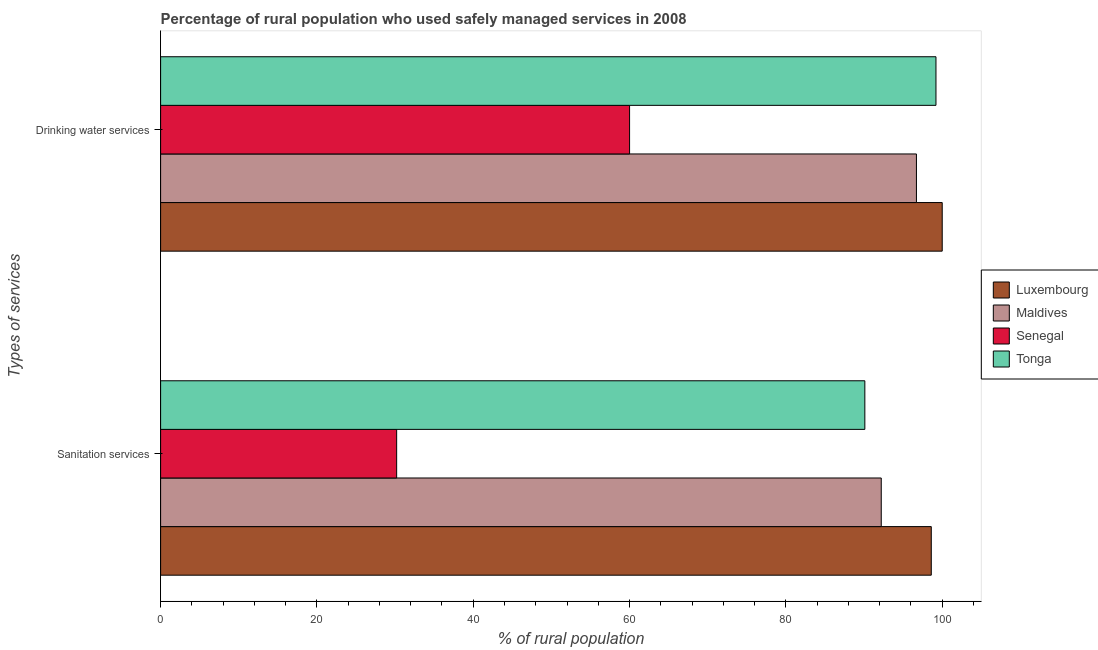How many bars are there on the 2nd tick from the bottom?
Offer a very short reply. 4. What is the label of the 1st group of bars from the top?
Provide a short and direct response. Drinking water services. What is the percentage of rural population who used sanitation services in Tonga?
Offer a very short reply. 90.1. Across all countries, what is the maximum percentage of rural population who used sanitation services?
Your answer should be very brief. 98.6. Across all countries, what is the minimum percentage of rural population who used sanitation services?
Make the answer very short. 30.2. In which country was the percentage of rural population who used drinking water services maximum?
Keep it short and to the point. Luxembourg. In which country was the percentage of rural population who used sanitation services minimum?
Provide a succinct answer. Senegal. What is the total percentage of rural population who used sanitation services in the graph?
Provide a succinct answer. 311.1. What is the difference between the percentage of rural population who used sanitation services in Luxembourg and that in Senegal?
Ensure brevity in your answer.  68.4. What is the difference between the percentage of rural population who used drinking water services in Senegal and the percentage of rural population who used sanitation services in Luxembourg?
Keep it short and to the point. -38.6. What is the average percentage of rural population who used sanitation services per country?
Make the answer very short. 77.78. What is the difference between the percentage of rural population who used drinking water services and percentage of rural population who used sanitation services in Luxembourg?
Your answer should be very brief. 1.4. What is the ratio of the percentage of rural population who used sanitation services in Senegal to that in Tonga?
Offer a terse response. 0.34. Is the percentage of rural population who used drinking water services in Luxembourg less than that in Senegal?
Ensure brevity in your answer.  No. What does the 4th bar from the top in Drinking water services represents?
Your response must be concise. Luxembourg. What does the 4th bar from the bottom in Drinking water services represents?
Keep it short and to the point. Tonga. Are all the bars in the graph horizontal?
Your response must be concise. Yes. Does the graph contain any zero values?
Offer a very short reply. No. Does the graph contain grids?
Ensure brevity in your answer.  No. Where does the legend appear in the graph?
Your answer should be compact. Center right. What is the title of the graph?
Give a very brief answer. Percentage of rural population who used safely managed services in 2008. What is the label or title of the X-axis?
Provide a succinct answer. % of rural population. What is the label or title of the Y-axis?
Make the answer very short. Types of services. What is the % of rural population of Luxembourg in Sanitation services?
Offer a very short reply. 98.6. What is the % of rural population in Maldives in Sanitation services?
Your answer should be compact. 92.2. What is the % of rural population in Senegal in Sanitation services?
Your answer should be very brief. 30.2. What is the % of rural population in Tonga in Sanitation services?
Offer a very short reply. 90.1. What is the % of rural population of Maldives in Drinking water services?
Make the answer very short. 96.7. What is the % of rural population of Senegal in Drinking water services?
Your response must be concise. 60. What is the % of rural population of Tonga in Drinking water services?
Ensure brevity in your answer.  99.2. Across all Types of services, what is the maximum % of rural population of Maldives?
Provide a short and direct response. 96.7. Across all Types of services, what is the maximum % of rural population in Tonga?
Keep it short and to the point. 99.2. Across all Types of services, what is the minimum % of rural population of Luxembourg?
Provide a short and direct response. 98.6. Across all Types of services, what is the minimum % of rural population in Maldives?
Your answer should be very brief. 92.2. Across all Types of services, what is the minimum % of rural population of Senegal?
Provide a succinct answer. 30.2. Across all Types of services, what is the minimum % of rural population of Tonga?
Your answer should be very brief. 90.1. What is the total % of rural population of Luxembourg in the graph?
Your answer should be compact. 198.6. What is the total % of rural population of Maldives in the graph?
Give a very brief answer. 188.9. What is the total % of rural population of Senegal in the graph?
Make the answer very short. 90.2. What is the total % of rural population of Tonga in the graph?
Give a very brief answer. 189.3. What is the difference between the % of rural population in Maldives in Sanitation services and that in Drinking water services?
Provide a succinct answer. -4.5. What is the difference between the % of rural population in Senegal in Sanitation services and that in Drinking water services?
Offer a very short reply. -29.8. What is the difference between the % of rural population of Luxembourg in Sanitation services and the % of rural population of Senegal in Drinking water services?
Ensure brevity in your answer.  38.6. What is the difference between the % of rural population in Maldives in Sanitation services and the % of rural population in Senegal in Drinking water services?
Make the answer very short. 32.2. What is the difference between the % of rural population in Senegal in Sanitation services and the % of rural population in Tonga in Drinking water services?
Make the answer very short. -69. What is the average % of rural population of Luxembourg per Types of services?
Offer a terse response. 99.3. What is the average % of rural population in Maldives per Types of services?
Keep it short and to the point. 94.45. What is the average % of rural population of Senegal per Types of services?
Provide a short and direct response. 45.1. What is the average % of rural population in Tonga per Types of services?
Your answer should be very brief. 94.65. What is the difference between the % of rural population of Luxembourg and % of rural population of Maldives in Sanitation services?
Provide a succinct answer. 6.4. What is the difference between the % of rural population of Luxembourg and % of rural population of Senegal in Sanitation services?
Your response must be concise. 68.4. What is the difference between the % of rural population of Luxembourg and % of rural population of Tonga in Sanitation services?
Your response must be concise. 8.5. What is the difference between the % of rural population in Maldives and % of rural population in Senegal in Sanitation services?
Provide a succinct answer. 62. What is the difference between the % of rural population of Maldives and % of rural population of Tonga in Sanitation services?
Make the answer very short. 2.1. What is the difference between the % of rural population of Senegal and % of rural population of Tonga in Sanitation services?
Offer a very short reply. -59.9. What is the difference between the % of rural population in Luxembourg and % of rural population in Tonga in Drinking water services?
Your answer should be very brief. 0.8. What is the difference between the % of rural population in Maldives and % of rural population in Senegal in Drinking water services?
Make the answer very short. 36.7. What is the difference between the % of rural population of Senegal and % of rural population of Tonga in Drinking water services?
Make the answer very short. -39.2. What is the ratio of the % of rural population of Luxembourg in Sanitation services to that in Drinking water services?
Provide a short and direct response. 0.99. What is the ratio of the % of rural population in Maldives in Sanitation services to that in Drinking water services?
Your response must be concise. 0.95. What is the ratio of the % of rural population in Senegal in Sanitation services to that in Drinking water services?
Your answer should be very brief. 0.5. What is the ratio of the % of rural population of Tonga in Sanitation services to that in Drinking water services?
Your answer should be compact. 0.91. What is the difference between the highest and the second highest % of rural population in Maldives?
Your answer should be very brief. 4.5. What is the difference between the highest and the second highest % of rural population of Senegal?
Your answer should be very brief. 29.8. What is the difference between the highest and the second highest % of rural population of Tonga?
Make the answer very short. 9.1. What is the difference between the highest and the lowest % of rural population of Senegal?
Provide a short and direct response. 29.8. 